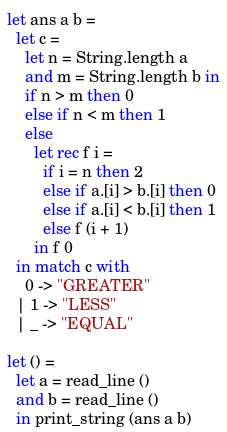Convert code to text. <code><loc_0><loc_0><loc_500><loc_500><_OCaml_>let ans a b =
  let c =
    let n = String.length a
    and m = String.length b in
    if n > m then 0
    else if n < m then 1
    else
      let rec f i =
        if i = n then 2
        else if a.[i] > b.[i] then 0
        else if a.[i] < b.[i] then 1
        else f (i + 1)
      in f 0
  in match c with
    0 -> "GREATER"
  | 1 -> "LESS"
  | _ -> "EQUAL"

let () =
  let a = read_line ()
  and b = read_line ()
  in print_string (ans a b)
</code> 